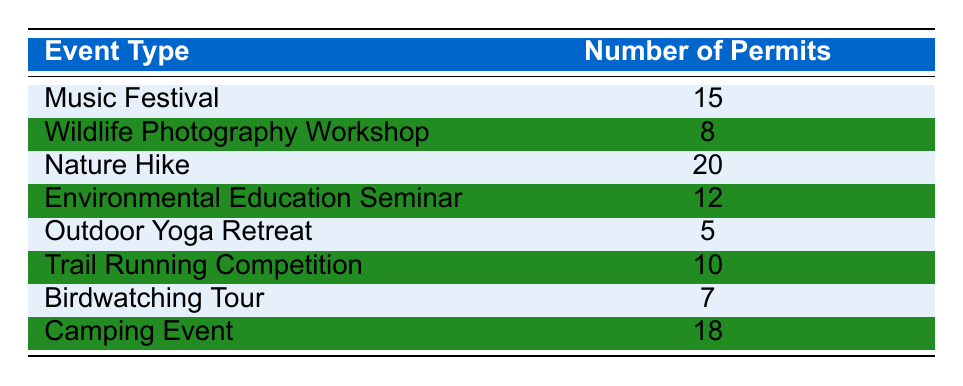What is the total number of permits issued for all events? To find the total number of permits, we need to sum the number of permits from each event type. The values are: 15 (Music Festival) + 8 (Wildlife Photography Workshop) + 20 (Nature Hike) + 12 (Environmental Education Seminar) + 5 (Outdoor Yoga Retreat) + 10 (Trail Running Competition) + 7 (Birdwatching Tour) + 18 (Camping Event) =  95.
Answer: 95 Which event type has the highest number of permits issued? By reviewing the table, I can see the number of permits for each event type. The event with the highest number of permits is the Nature Hike with 20 permits.
Answer: Nature Hike How many permits were issued for all types of yoga events combined? The only yoga-related event listed is the Outdoor Yoga Retreat, which has 5 permits issued. Therefore, the total for yoga events is 5.
Answer: 5 Is the number of permits issued for the Camping Event greater than that of the Birdwatching Tour? The Camping Event has 18 permits while the Birdwatching Tour has 7 permits. Since 18 is greater than 7, the statement is true.
Answer: Yes What is the average number of permits issued per event type? To calculate the average, I need to sum the number of permits (95 from the first question) and divide by the number of event types, which is 8. So, 95 / 8 = 11.875. The average is approximately 11.875.
Answer: 11.875 How many more permits were issued for Nature Hike compared to Environmental Education Seminar? The Nature Hike issued 20 permits and the Environmental Education Seminar issued 12 permits. The difference is 20 - 12 = 8. Thus, 8 more permits were issued for Nature Hike.
Answer: 8 Are there any events with fewer than 10 permits issued? Events that have fewer than 10 permits are Outdoor Yoga Retreat (5 permits), Wildlife Photography Workshop (8 permits), and Birdwatching Tour (7 permits). Thus, there are events with fewer than 10 permits.
Answer: Yes What is the total number of permits for events with event types that include "Workshop"? The only workshop listed is the Wildlife Photography Workshop, which has 8 permits. Therefore, the total number of permits for events with workshop types is 8.
Answer: 8 Which event types issued between 10 and 15 permits? From the table, the events that issued between 10 and 15 permits are the Music Festival (15 permits) and the Trail Running Competition (10 permits).
Answer: Music Festival, Trail Running Competition 